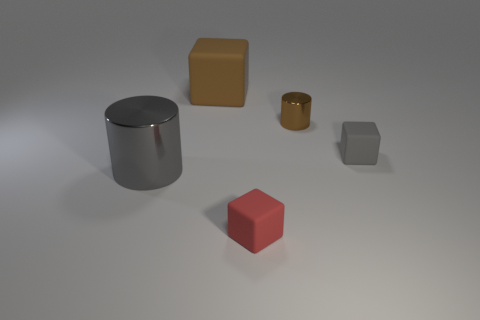Could you speculate on the sizes of these objects relative to each other? While direct measurements cannot be made from the image alone, relative sizes can be speculated. The gray metal cylinder appears to be the largest object, followed by the yellow and red cubes which seem to be of identical dimensions. The smaller brown cylinder looks to be the smallest object in the group. The arrangement presents an interesting composition, perhaps meant to compare and contrast the visual impact of different geometric forms and colors. 